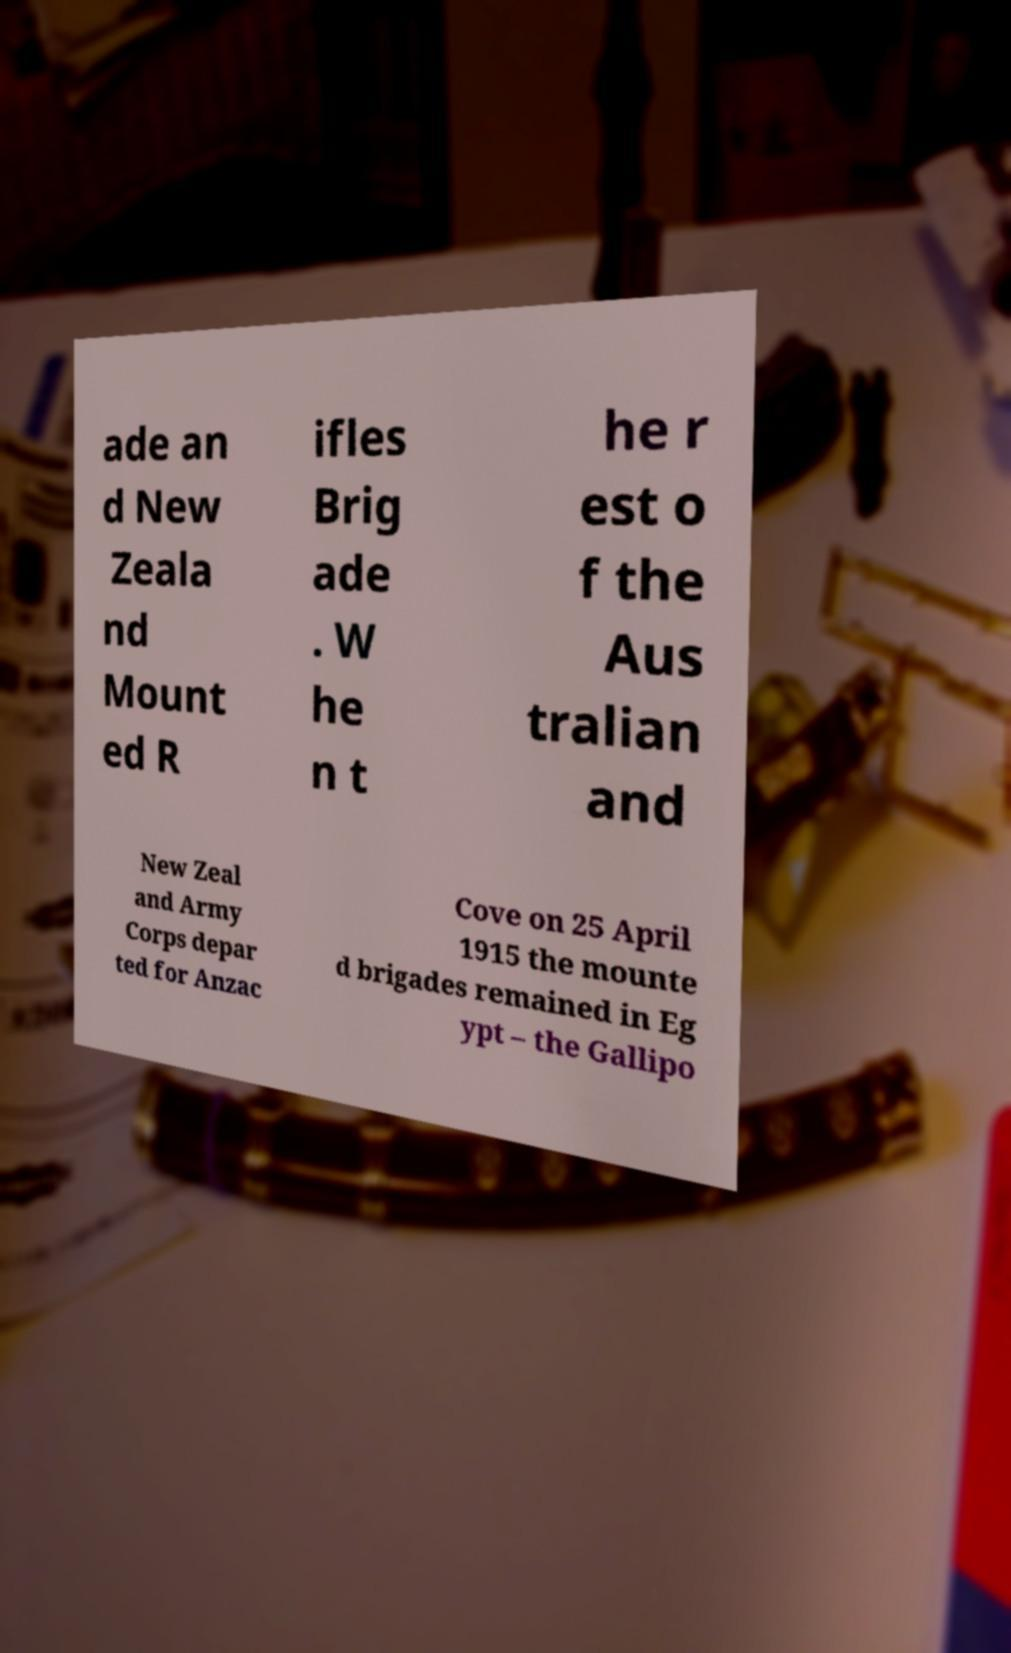I need the written content from this picture converted into text. Can you do that? ade an d New Zeala nd Mount ed R ifles Brig ade . W he n t he r est o f the Aus tralian and New Zeal and Army Corps depar ted for Anzac Cove on 25 April 1915 the mounte d brigades remained in Eg ypt – the Gallipo 